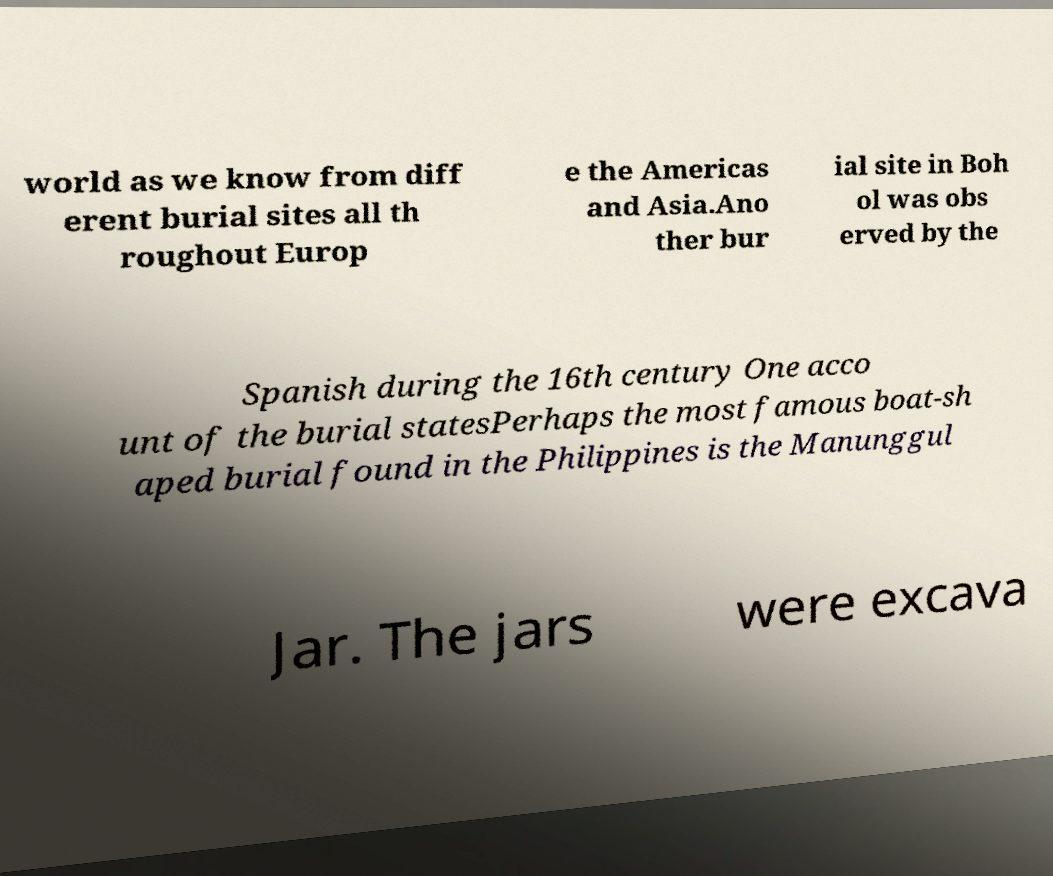For documentation purposes, I need the text within this image transcribed. Could you provide that? world as we know from diff erent burial sites all th roughout Europ e the Americas and Asia.Ano ther bur ial site in Boh ol was obs erved by the Spanish during the 16th century One acco unt of the burial statesPerhaps the most famous boat-sh aped burial found in the Philippines is the Manunggul Jar. The jars were excava 